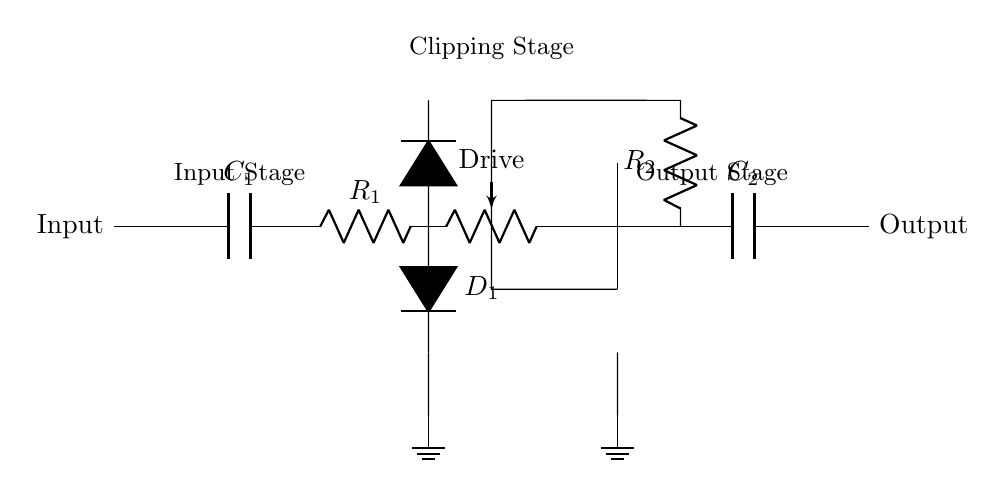What does the input capacitor do in this circuit? The input capacitor, labeled as C1, serves to block any DC voltage while allowing AC signals (such as the guitar's audio signal) to pass through, effectively coupling the input signal to the rest of the circuit.
Answer: Blocks DC, allows AC What type of diodes are used in the clipping stage? The circuit diagram shows two symbolically indicated diodes (D1 and its counterpart), which are typically silicon diodes, used for clipping the signal at a certain threshold to create overdrive.
Answer: Silicon diodes What is the function of the potentiometer labeled as "Drive"? The potentiometer, labeled "Drive," adjusts the amount of gain applied to the signal before it reaches the op-amp, allowing the player to control the distortion level from the pedal.
Answer: Adjusts gain How many resistors are present in this circuit? There are two resistors in the circuit, labeled R1 and R2. R1 is involved in the input stage, and R2 is part of the feedback loop of the op-amp.
Answer: Two resistors What role does the output capacitor play in this circuit? The output capacitor, labeled C2, serves as a coupling capacitor, blocking any DC component of the signal at the output while allowing the AC guitar signal to pass, ensuring that the final output is clean for the next stage.
Answer: Blocks DC at output What happens to the signal voltage at the clipping stage? At the clipping stage, the signal voltage is limited by the diodes (D1), which prevent the voltage from exceeding a specific level, effectively creating distortion in the guitar tone when the signal exceeds this threshold.
Answer: Voltage limited by diodes What is the purpose of the op-amp in the circuit? The op-amp amplifies the guitar signal, allowing for a stronger output signal and contributing to the overall distortion effect when combined with feedback from R2.
Answer: Amplifies guitar signal 